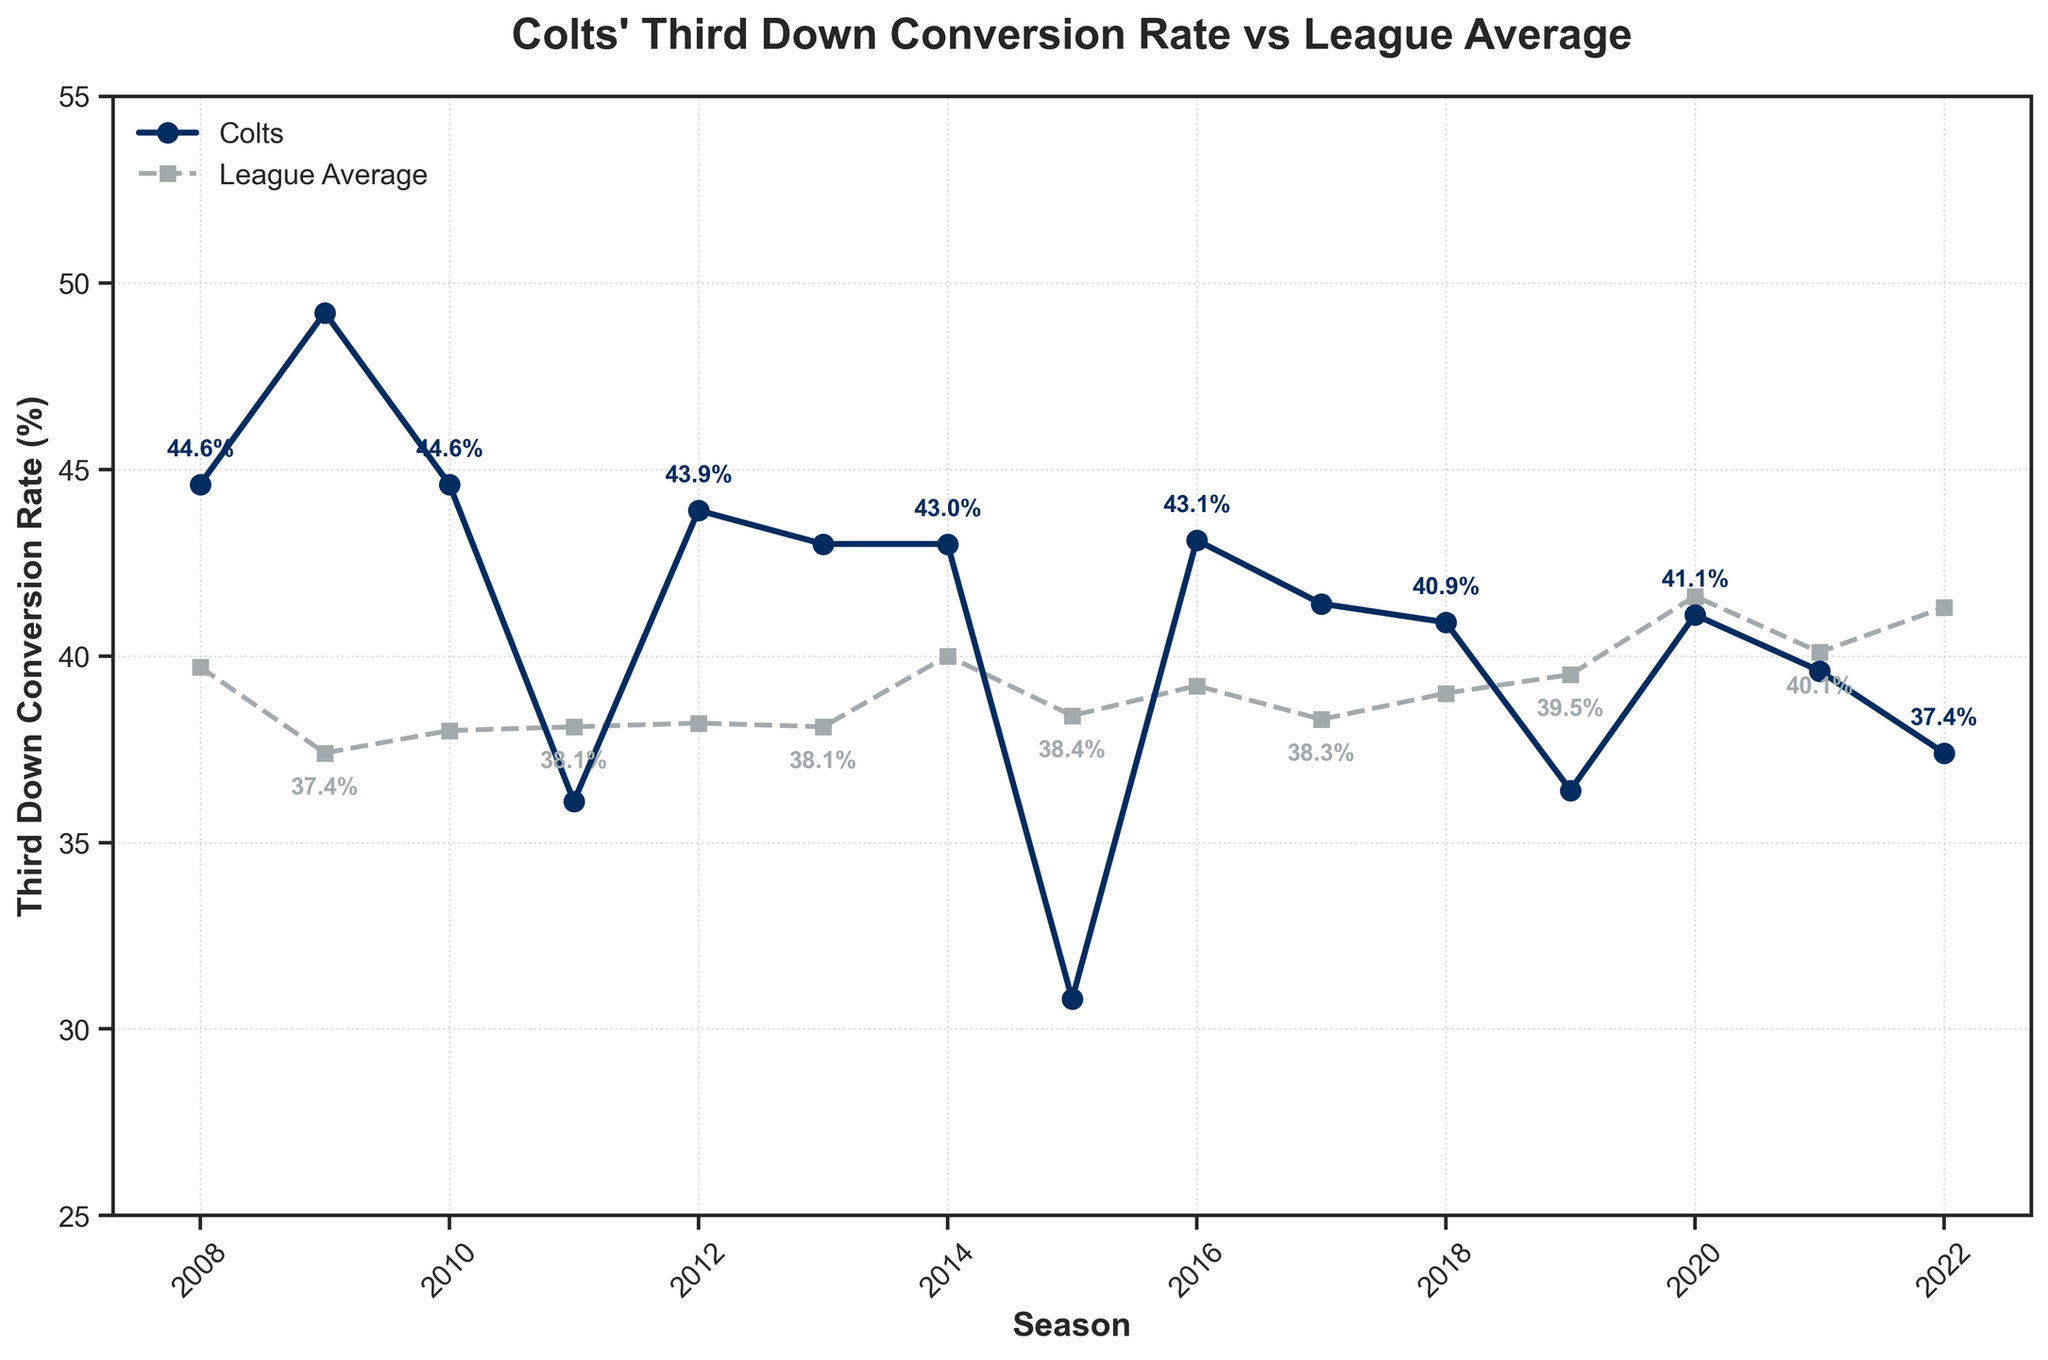Which season had the highest third-down conversion rate for the Colts? By looking at the line labeled "Colts" (marked with circles), the highest point on this line represents the highest conversion rate, which occurs in 2009.
Answer: 2009 In comparison to the league average, how did the Colts perform in the 2015 season? Compare the values for the 2015 season from both the Colts (30.8%) and League Average (38.4%) lines. The Colts' rate is lower than the league average that year.
Answer: Worse What trend can you see in the Colts' third-down conversion rate from 2011 to 2013? By following the trajectory of the line from 2011 to 2013, the Colts' conversion rate shows a significant increase in 2012 followed by a slight decrease in 2013.
Answer: Increases then slightly decreases In which years did the Colts' third-down conversion rate drop below the league average? Look for the years where the Colts' line is below the league average line: specifically, 2011, 2015, 2019, 2020, 2021, and 2022.
Answer: 2011, 2015, 2019, 2020, 2021, 2022 What is the difference between the Colts' and the league average's third-down conversion rate in 2022? Subtract the Colts’ 2022 rate (37.4%) from the league average rate (41.3%). The difference is 3.9%.
Answer: 3.9% How did the Colts' performance in third-down conversions change from 2009 to 2010? Compare the rates from 2009 (49.2%) and 2010 (44.6%). There is a decline of 4.6%.
Answer: Decreased by 4.6% Between which consecutive seasons did the Colts experience the largest drop in third-down conversion rate? By examining the data points year by year, the largest drop occurs between 2014 (43.0%) and 2015 (30.8%), which is 12.2%.
Answer: 2014 to 2015 What visual differences can you spot between the lines representing the Colts and the league average? The Colts' line is represented by circles and solid lines, while the league average line is represented by squares and dashed lines.
Answer: Circles and solid vs. squares and dashed 